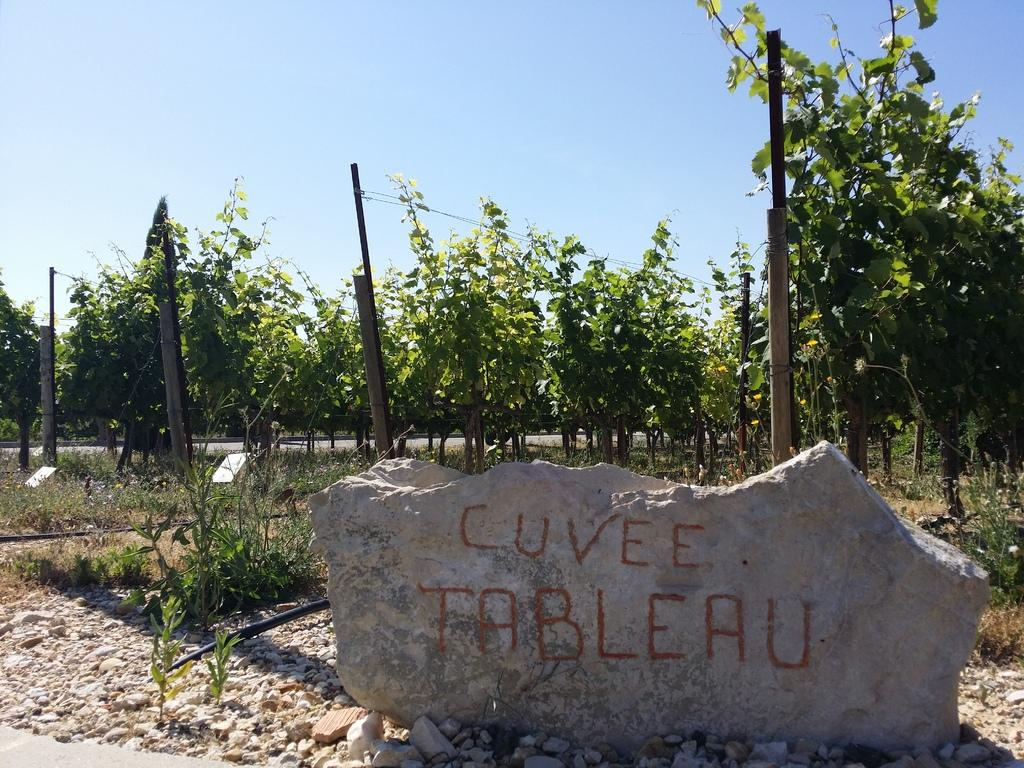What type of vegetation can be seen in the image? There are trees and a plant in the image. What man-made structure is visible in the image? There is a road in the image. What object made of stone can be seen in the image? There is a stone in the image. What is being secured in the image? Stocks are tied in the image. What is visible at the top of the image? The sky is visible at the top of the image. Can you tell me how much salt is being used in the image? There is no salt present in the image. What type of harbor can be seen in the image? There is no harbor present in the image. 